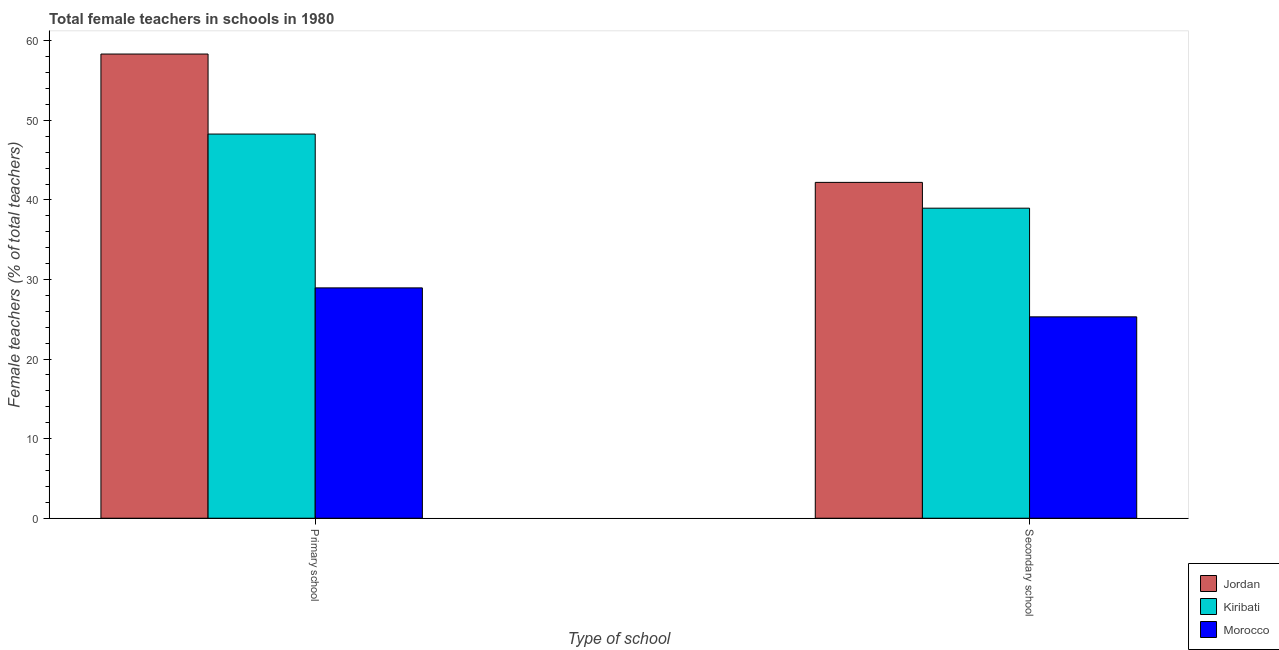How many different coloured bars are there?
Give a very brief answer. 3. How many groups of bars are there?
Make the answer very short. 2. Are the number of bars per tick equal to the number of legend labels?
Make the answer very short. Yes. Are the number of bars on each tick of the X-axis equal?
Your response must be concise. Yes. How many bars are there on the 2nd tick from the left?
Your response must be concise. 3. How many bars are there on the 2nd tick from the right?
Provide a short and direct response. 3. What is the label of the 2nd group of bars from the left?
Make the answer very short. Secondary school. What is the percentage of female teachers in secondary schools in Jordan?
Provide a succinct answer. 42.2. Across all countries, what is the maximum percentage of female teachers in primary schools?
Give a very brief answer. 58.33. Across all countries, what is the minimum percentage of female teachers in primary schools?
Provide a short and direct response. 28.95. In which country was the percentage of female teachers in secondary schools maximum?
Keep it short and to the point. Jordan. In which country was the percentage of female teachers in secondary schools minimum?
Your answer should be compact. Morocco. What is the total percentage of female teachers in primary schools in the graph?
Provide a succinct answer. 135.55. What is the difference between the percentage of female teachers in primary schools in Kiribati and that in Morocco?
Offer a very short reply. 19.33. What is the difference between the percentage of female teachers in secondary schools in Jordan and the percentage of female teachers in primary schools in Morocco?
Offer a terse response. 13.26. What is the average percentage of female teachers in primary schools per country?
Make the answer very short. 45.18. What is the difference between the percentage of female teachers in primary schools and percentage of female teachers in secondary schools in Jordan?
Offer a very short reply. 16.13. What is the ratio of the percentage of female teachers in secondary schools in Jordan to that in Morocco?
Keep it short and to the point. 1.67. What does the 2nd bar from the left in Primary school represents?
Make the answer very short. Kiribati. What does the 2nd bar from the right in Primary school represents?
Ensure brevity in your answer.  Kiribati. Are all the bars in the graph horizontal?
Offer a terse response. No. Does the graph contain any zero values?
Make the answer very short. No. Does the graph contain grids?
Offer a very short reply. No. Where does the legend appear in the graph?
Your response must be concise. Bottom right. What is the title of the graph?
Your answer should be very brief. Total female teachers in schools in 1980. What is the label or title of the X-axis?
Provide a short and direct response. Type of school. What is the label or title of the Y-axis?
Offer a very short reply. Female teachers (% of total teachers). What is the Female teachers (% of total teachers) of Jordan in Primary school?
Ensure brevity in your answer.  58.33. What is the Female teachers (% of total teachers) in Kiribati in Primary school?
Offer a terse response. 48.28. What is the Female teachers (% of total teachers) of Morocco in Primary school?
Keep it short and to the point. 28.95. What is the Female teachers (% of total teachers) of Jordan in Secondary school?
Offer a terse response. 42.2. What is the Female teachers (% of total teachers) of Kiribati in Secondary school?
Your answer should be very brief. 38.96. What is the Female teachers (% of total teachers) in Morocco in Secondary school?
Give a very brief answer. 25.31. Across all Type of school, what is the maximum Female teachers (% of total teachers) of Jordan?
Give a very brief answer. 58.33. Across all Type of school, what is the maximum Female teachers (% of total teachers) of Kiribati?
Provide a short and direct response. 48.28. Across all Type of school, what is the maximum Female teachers (% of total teachers) of Morocco?
Offer a very short reply. 28.95. Across all Type of school, what is the minimum Female teachers (% of total teachers) of Jordan?
Give a very brief answer. 42.2. Across all Type of school, what is the minimum Female teachers (% of total teachers) of Kiribati?
Provide a short and direct response. 38.96. Across all Type of school, what is the minimum Female teachers (% of total teachers) of Morocco?
Provide a short and direct response. 25.31. What is the total Female teachers (% of total teachers) of Jordan in the graph?
Make the answer very short. 100.54. What is the total Female teachers (% of total teachers) in Kiribati in the graph?
Provide a short and direct response. 87.24. What is the total Female teachers (% of total teachers) in Morocco in the graph?
Keep it short and to the point. 54.25. What is the difference between the Female teachers (% of total teachers) of Jordan in Primary school and that in Secondary school?
Give a very brief answer. 16.13. What is the difference between the Female teachers (% of total teachers) of Kiribati in Primary school and that in Secondary school?
Your answer should be very brief. 9.31. What is the difference between the Female teachers (% of total teachers) in Morocco in Primary school and that in Secondary school?
Your response must be concise. 3.64. What is the difference between the Female teachers (% of total teachers) in Jordan in Primary school and the Female teachers (% of total teachers) in Kiribati in Secondary school?
Make the answer very short. 19.37. What is the difference between the Female teachers (% of total teachers) of Jordan in Primary school and the Female teachers (% of total teachers) of Morocco in Secondary school?
Your answer should be compact. 33.03. What is the difference between the Female teachers (% of total teachers) of Kiribati in Primary school and the Female teachers (% of total teachers) of Morocco in Secondary school?
Your answer should be compact. 22.97. What is the average Female teachers (% of total teachers) of Jordan per Type of school?
Your response must be concise. 50.27. What is the average Female teachers (% of total teachers) in Kiribati per Type of school?
Keep it short and to the point. 43.62. What is the average Female teachers (% of total teachers) in Morocco per Type of school?
Offer a terse response. 27.13. What is the difference between the Female teachers (% of total teachers) in Jordan and Female teachers (% of total teachers) in Kiribati in Primary school?
Provide a succinct answer. 10.06. What is the difference between the Female teachers (% of total teachers) in Jordan and Female teachers (% of total teachers) in Morocco in Primary school?
Your answer should be compact. 29.39. What is the difference between the Female teachers (% of total teachers) in Kiribati and Female teachers (% of total teachers) in Morocco in Primary school?
Your response must be concise. 19.33. What is the difference between the Female teachers (% of total teachers) in Jordan and Female teachers (% of total teachers) in Kiribati in Secondary school?
Make the answer very short. 3.24. What is the difference between the Female teachers (% of total teachers) in Jordan and Female teachers (% of total teachers) in Morocco in Secondary school?
Your answer should be very brief. 16.9. What is the difference between the Female teachers (% of total teachers) of Kiribati and Female teachers (% of total teachers) of Morocco in Secondary school?
Your answer should be compact. 13.66. What is the ratio of the Female teachers (% of total teachers) of Jordan in Primary school to that in Secondary school?
Offer a very short reply. 1.38. What is the ratio of the Female teachers (% of total teachers) in Kiribati in Primary school to that in Secondary school?
Keep it short and to the point. 1.24. What is the ratio of the Female teachers (% of total teachers) of Morocco in Primary school to that in Secondary school?
Provide a succinct answer. 1.14. What is the difference between the highest and the second highest Female teachers (% of total teachers) of Jordan?
Your answer should be compact. 16.13. What is the difference between the highest and the second highest Female teachers (% of total teachers) of Kiribati?
Provide a short and direct response. 9.31. What is the difference between the highest and the second highest Female teachers (% of total teachers) of Morocco?
Give a very brief answer. 3.64. What is the difference between the highest and the lowest Female teachers (% of total teachers) in Jordan?
Keep it short and to the point. 16.13. What is the difference between the highest and the lowest Female teachers (% of total teachers) of Kiribati?
Keep it short and to the point. 9.31. What is the difference between the highest and the lowest Female teachers (% of total teachers) of Morocco?
Provide a succinct answer. 3.64. 